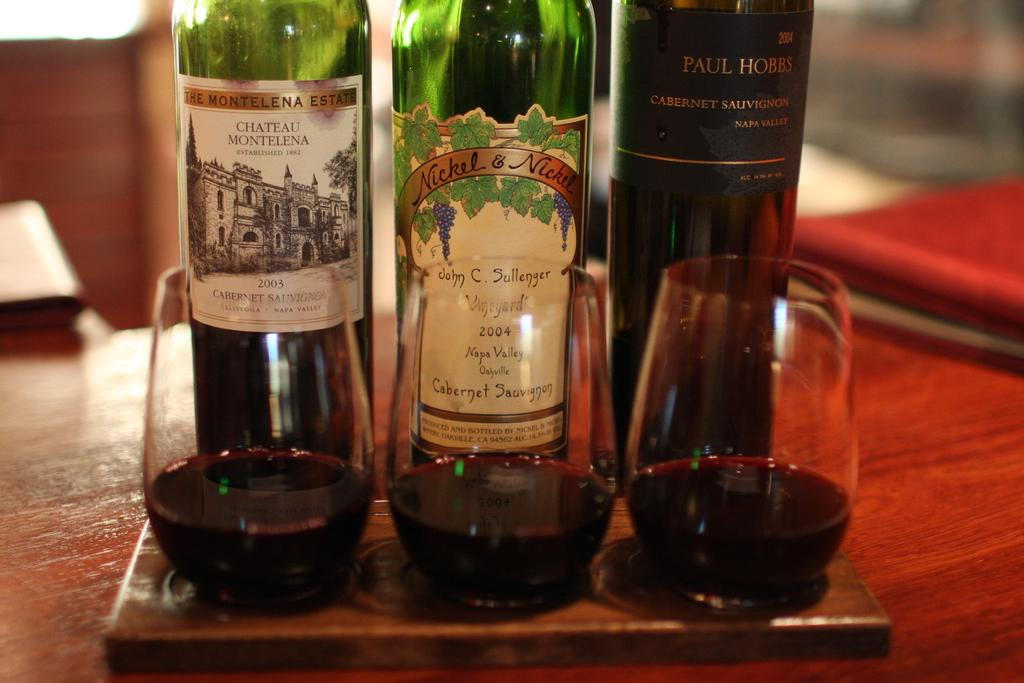<image>
Render a clear and concise summary of the photo. Three bottles of wine, all Cabernets, lined up with partially filled glasses in front of them. 